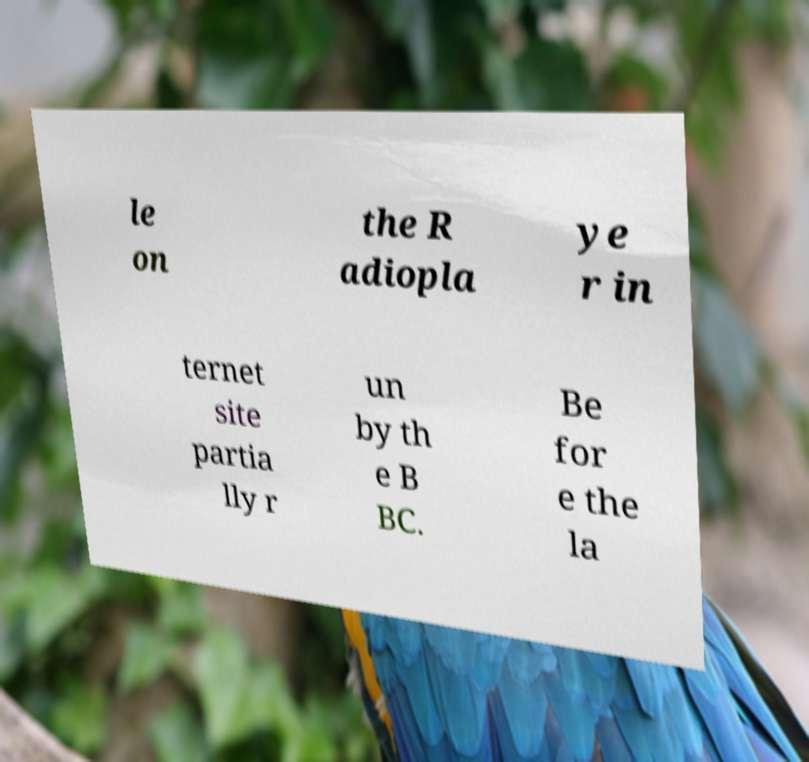Can you read and provide the text displayed in the image?This photo seems to have some interesting text. Can you extract and type it out for me? le on the R adiopla ye r in ternet site partia lly r un by th e B BC. Be for e the la 